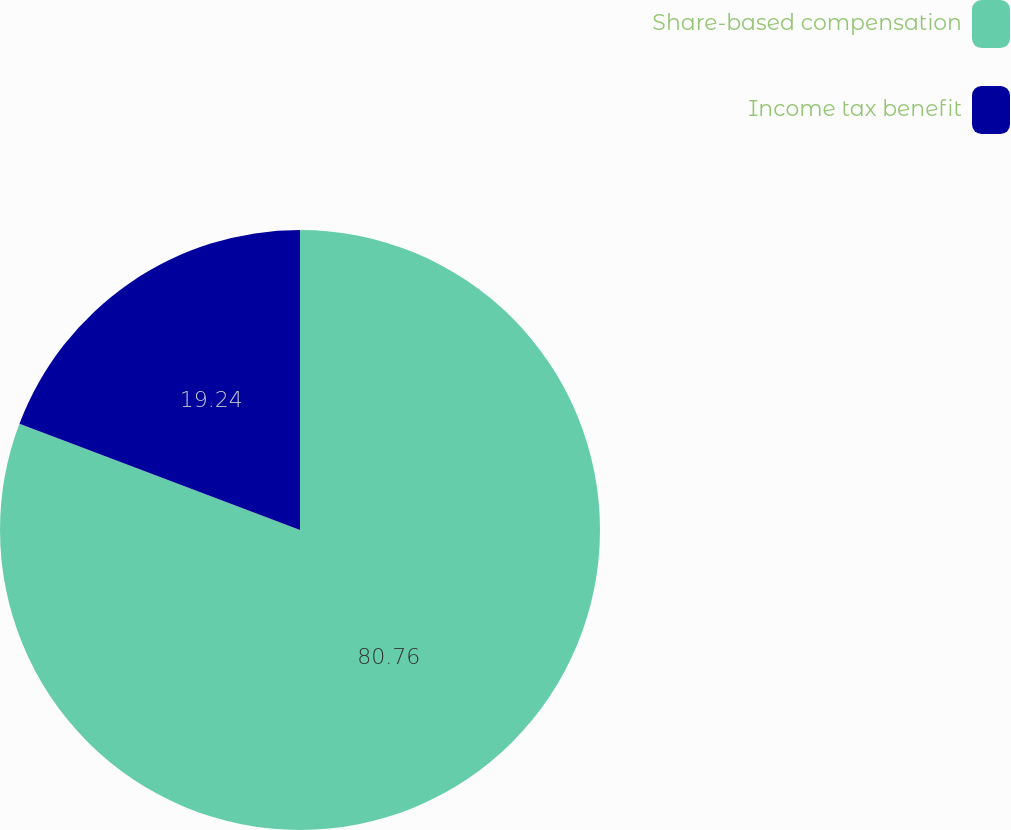Convert chart. <chart><loc_0><loc_0><loc_500><loc_500><pie_chart><fcel>Share-based compensation<fcel>Income tax benefit<nl><fcel>80.76%<fcel>19.24%<nl></chart> 